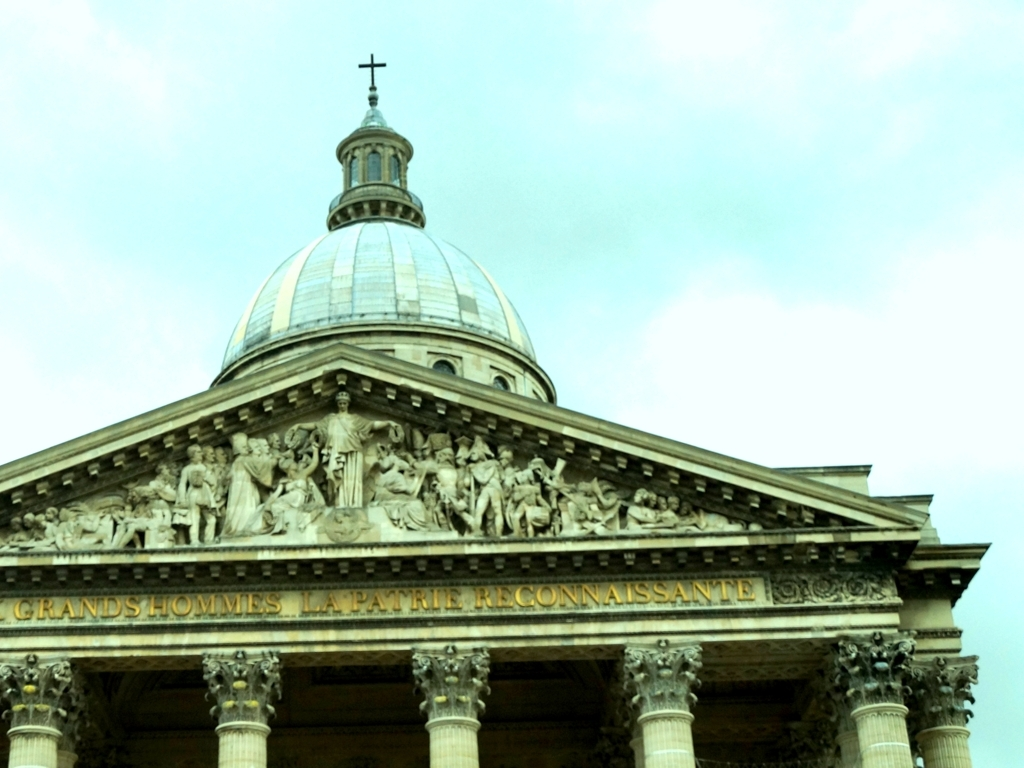What architectural style is shown in this image? The image features a neoclassical architectural style, characterized by the grand columns, symmetrical design, and elaborate frieze depicted above the columns. Can you tell me more about the frieze? The frieze appears to depict a historical or allegorical scene with multiple figures, possibly representing notable personages or events relevant to the underlying theme of the building, which could be associated with national pride or cultural achievements. 